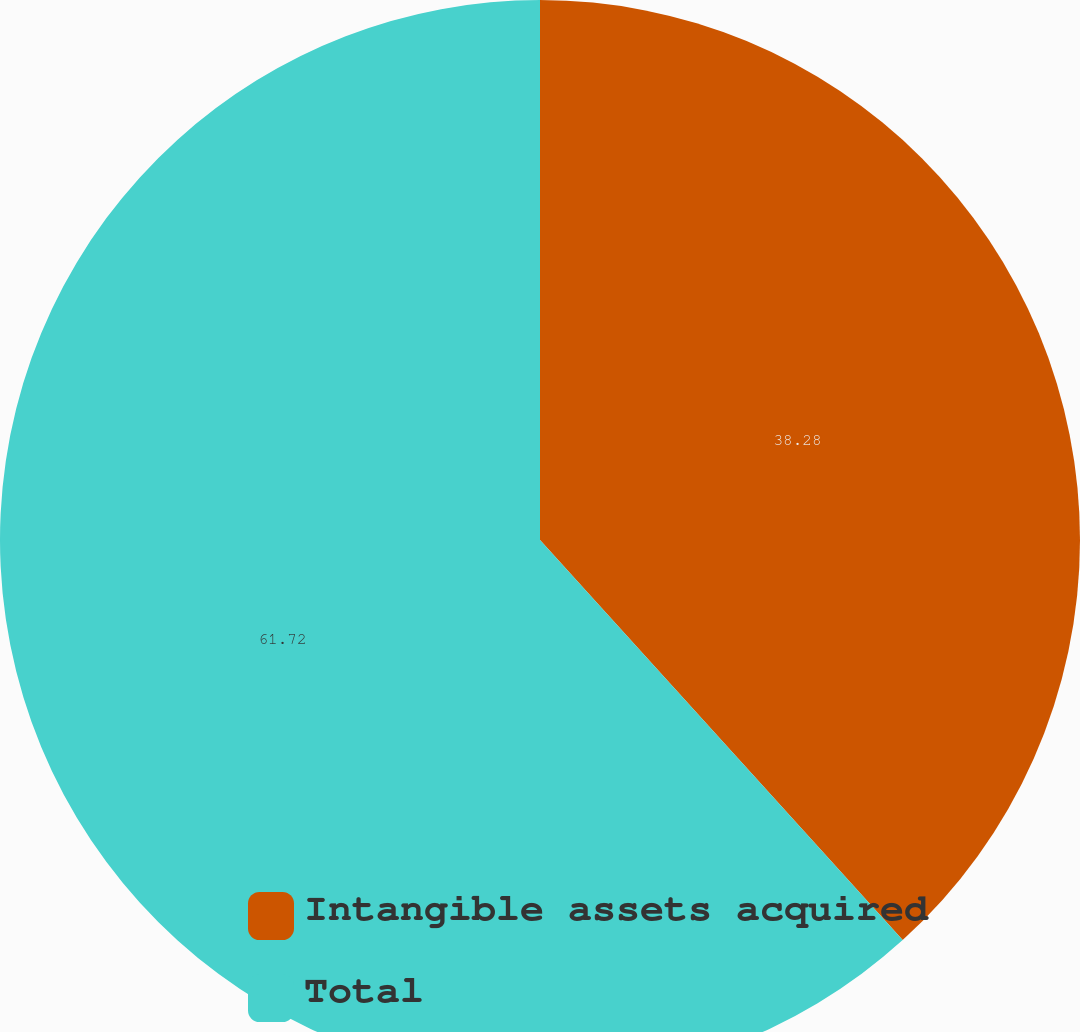Convert chart. <chart><loc_0><loc_0><loc_500><loc_500><pie_chart><fcel>Intangible assets acquired<fcel>Total<nl><fcel>38.28%<fcel>61.72%<nl></chart> 